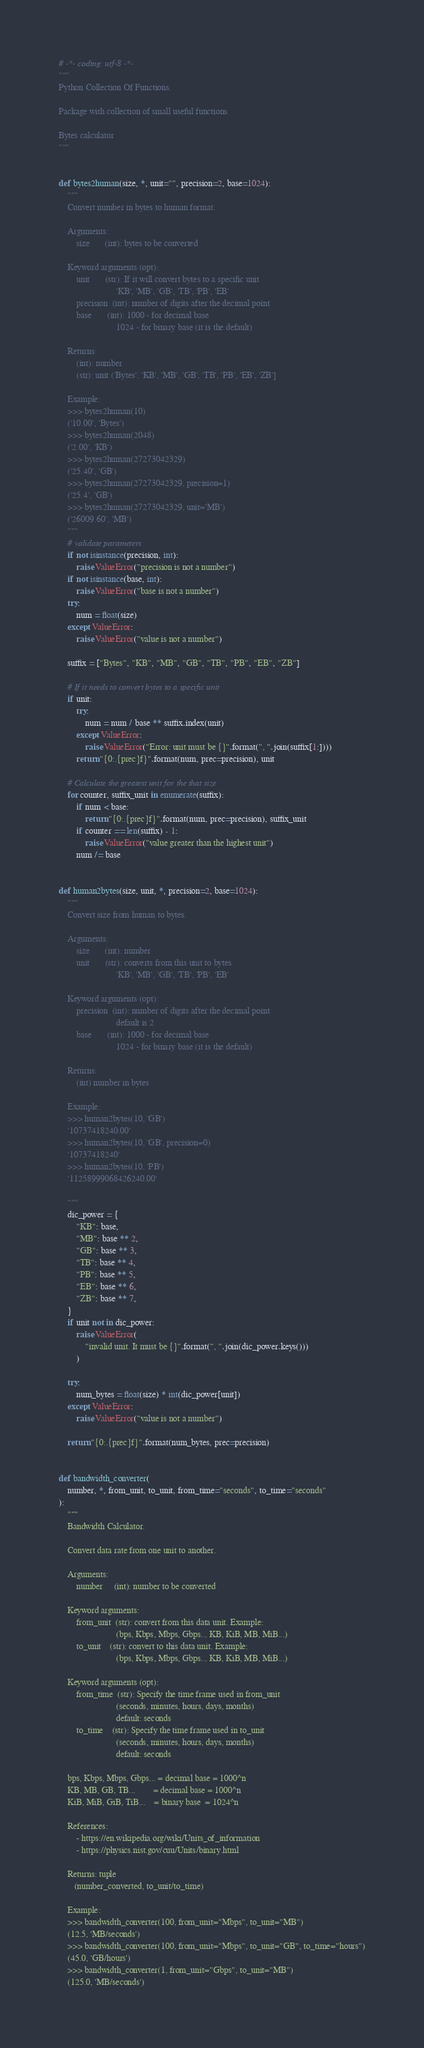<code> <loc_0><loc_0><loc_500><loc_500><_Python_># -*- coding: utf-8 -*-
"""
Python Collection Of Functions.

Package with collection of small useful functions.

Bytes calculator
"""


def bytes2human(size, *, unit="", precision=2, base=1024):
    """
    Convert number in bytes to human format.

    Arguments:
        size       (int): bytes to be converted

    Keyword arguments (opt):
        unit       (str): If it will convert bytes to a specific unit
                          'KB', 'MB', 'GB', 'TB', 'PB', 'EB'
        precision  (int): number of digits after the decimal point
        base       (int): 1000 - for decimal base
                          1024 - for binary base (it is the default)

    Returns:
        (int): number
        (str): unit ('Bytes', 'KB', 'MB', 'GB', 'TB', 'PB', 'EB', 'ZB']

    Example:
    >>> bytes2human(10)
    ('10.00', 'Bytes')
    >>> bytes2human(2048)
    ('2.00', 'KB')
    >>> bytes2human(27273042329)
    ('25.40', 'GB')
    >>> bytes2human(27273042329, precision=1)
    ('25.4', 'GB')
    >>> bytes2human(27273042329, unit='MB')
    ('26009.60', 'MB')
    """
    # validate parameters
    if not isinstance(precision, int):
        raise ValueError("precision is not a number")
    if not isinstance(base, int):
        raise ValueError("base is not a number")
    try:
        num = float(size)
    except ValueError:
        raise ValueError("value is not a number")

    suffix = ["Bytes", "KB", "MB", "GB", "TB", "PB", "EB", "ZB"]

    # If it needs to convert bytes to a specific unit
    if unit:
        try:
            num = num / base ** suffix.index(unit)
        except ValueError:
            raise ValueError("Error: unit must be {}".format(", ".join(suffix[1:])))
        return "{0:.{prec}f}".format(num, prec=precision), unit

    # Calculate the greatest unit for the that size
    for counter, suffix_unit in enumerate(suffix):
        if num < base:
            return "{0:.{prec}f}".format(num, prec=precision), suffix_unit
        if counter == len(suffix) - 1:
            raise ValueError("value greater than the highest unit")
        num /= base


def human2bytes(size, unit, *, precision=2, base=1024):
    """
    Convert size from human to bytes.

    Arguments:
        size       (int): number
        unit       (str): converts from this unit to bytes
                          'KB', 'MB', 'GB', 'TB', 'PB', 'EB'

    Keyword arguments (opt):
        precision  (int): number of digits after the decimal point
                          default is 2
        base       (int): 1000 - for decimal base
                          1024 - for binary base (it is the default)

    Returns:
        (int) number in bytes

    Example:
    >>> human2bytes(10, 'GB')
    '10737418240.00'
    >>> human2bytes(10, 'GB', precision=0)
    '10737418240'
    >>> human2bytes(10, 'PB')
    '11258999068426240.00'

    """
    dic_power = {
        "KB": base,
        "MB": base ** 2,
        "GB": base ** 3,
        "TB": base ** 4,
        "PB": base ** 5,
        "EB": base ** 6,
        "ZB": base ** 7,
    }
    if unit not in dic_power:
        raise ValueError(
            "invalid unit. It must be {}".format(", ".join(dic_power.keys()))
        )

    try:
        num_bytes = float(size) * int(dic_power[unit])
    except ValueError:
        raise ValueError("value is not a number")

    return "{0:.{prec}f}".format(num_bytes, prec=precision)


def bandwidth_converter(
    number, *, from_unit, to_unit, from_time="seconds", to_time="seconds"
):
    """
    Bandwidth Calculator.

    Convert data rate from one unit to another.

    Arguments:
        number     (int): number to be converted

    Keyword arguments:
        from_unit  (str): convert from this data unit. Example:
                          (bps, Kbps, Mbps, Gbps... KB, KiB, MB, MiB...)
        to_unit    (str): convert to this data unit. Example:
                          (bps, Kbps, Mbps, Gbps... KB, KiB, MB, MiB...)

    Keyword arguments (opt):
        from_time  (str): Specify the time frame used in from_unit
                          (seconds, minutes, hours, days, months)
                          default: seconds
        to_time    (str): Specify the time frame used in to_unit
                          (seconds, minutes, hours, days, months)
                          default: seconds

    bps, Kbps, Mbps, Gbps... = decimal base = 1000^n
    KB, MB, GB, TB...        = decimal base = 1000^n
    KiB, MiB, GiB, TiB...    = binary base  = 1024^n

    References:
        - https://en.wikipedia.org/wiki/Units_of_information
        - https://physics.nist.gov/cuu/Units/binary.html

    Returns: tuple
       (number_converted, to_unit/to_time)

    Example:
    >>> bandwidth_converter(100, from_unit="Mbps", to_unit="MB")
    (12.5, 'MB/seconds')
    >>> bandwidth_converter(100, from_unit="Mbps", to_unit="GB", to_time="hours")
    (45.0, 'GB/hours')
    >>> bandwidth_converter(1, from_unit="Gbps", to_unit="MB")
    (125.0, 'MB/seconds')</code> 